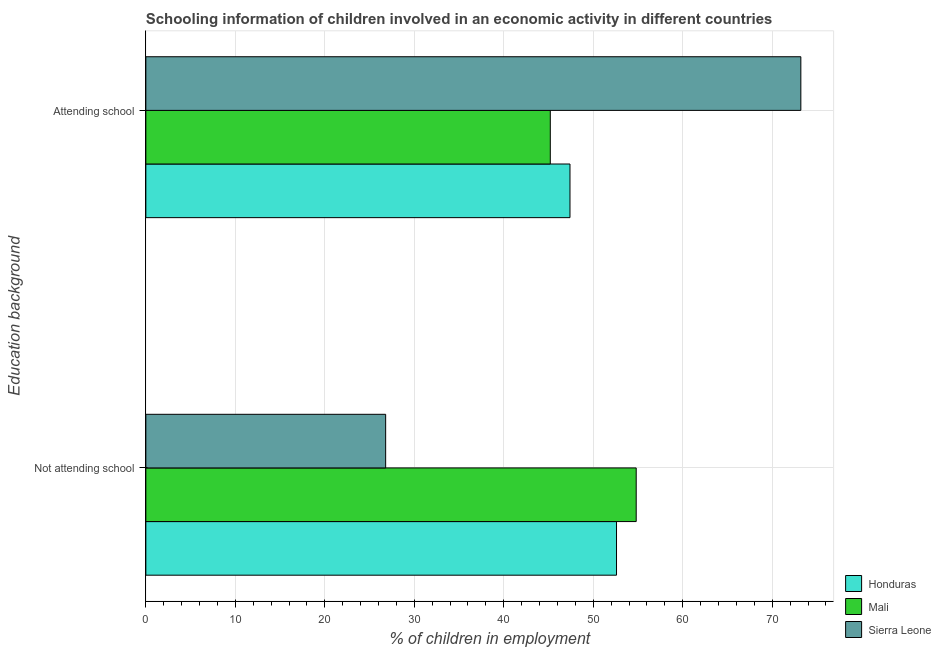How many different coloured bars are there?
Give a very brief answer. 3. Are the number of bars per tick equal to the number of legend labels?
Offer a terse response. Yes. What is the label of the 1st group of bars from the top?
Give a very brief answer. Attending school. What is the percentage of employed children who are attending school in Mali?
Offer a terse response. 45.2. Across all countries, what is the maximum percentage of employed children who are attending school?
Keep it short and to the point. 73.2. Across all countries, what is the minimum percentage of employed children who are not attending school?
Offer a terse response. 26.8. In which country was the percentage of employed children who are attending school maximum?
Offer a very short reply. Sierra Leone. In which country was the percentage of employed children who are not attending school minimum?
Provide a short and direct response. Sierra Leone. What is the total percentage of employed children who are not attending school in the graph?
Offer a terse response. 134.2. What is the difference between the percentage of employed children who are attending school in Sierra Leone and that in Honduras?
Ensure brevity in your answer.  25.8. What is the difference between the percentage of employed children who are not attending school in Mali and the percentage of employed children who are attending school in Honduras?
Keep it short and to the point. 7.4. What is the average percentage of employed children who are not attending school per country?
Ensure brevity in your answer.  44.73. What is the difference between the percentage of employed children who are not attending school and percentage of employed children who are attending school in Honduras?
Give a very brief answer. 5.2. What is the ratio of the percentage of employed children who are not attending school in Honduras to that in Mali?
Give a very brief answer. 0.96. What does the 1st bar from the top in Attending school represents?
Offer a very short reply. Sierra Leone. What does the 2nd bar from the bottom in Not attending school represents?
Offer a terse response. Mali. How many countries are there in the graph?
Keep it short and to the point. 3. What is the difference between two consecutive major ticks on the X-axis?
Your answer should be very brief. 10. Does the graph contain grids?
Provide a short and direct response. Yes. How many legend labels are there?
Offer a very short reply. 3. What is the title of the graph?
Offer a very short reply. Schooling information of children involved in an economic activity in different countries. Does "Mauritania" appear as one of the legend labels in the graph?
Your answer should be compact. No. What is the label or title of the X-axis?
Give a very brief answer. % of children in employment. What is the label or title of the Y-axis?
Offer a very short reply. Education background. What is the % of children in employment of Honduras in Not attending school?
Provide a succinct answer. 52.6. What is the % of children in employment of Mali in Not attending school?
Offer a terse response. 54.8. What is the % of children in employment in Sierra Leone in Not attending school?
Provide a succinct answer. 26.8. What is the % of children in employment in Honduras in Attending school?
Your answer should be very brief. 47.4. What is the % of children in employment of Mali in Attending school?
Offer a very short reply. 45.2. What is the % of children in employment in Sierra Leone in Attending school?
Keep it short and to the point. 73.2. Across all Education background, what is the maximum % of children in employment of Honduras?
Make the answer very short. 52.6. Across all Education background, what is the maximum % of children in employment in Mali?
Provide a short and direct response. 54.8. Across all Education background, what is the maximum % of children in employment in Sierra Leone?
Your answer should be very brief. 73.2. Across all Education background, what is the minimum % of children in employment of Honduras?
Keep it short and to the point. 47.4. Across all Education background, what is the minimum % of children in employment of Mali?
Ensure brevity in your answer.  45.2. Across all Education background, what is the minimum % of children in employment of Sierra Leone?
Provide a succinct answer. 26.8. What is the total % of children in employment of Honduras in the graph?
Offer a terse response. 100. What is the total % of children in employment in Sierra Leone in the graph?
Your answer should be compact. 100. What is the difference between the % of children in employment in Honduras in Not attending school and that in Attending school?
Give a very brief answer. 5.2. What is the difference between the % of children in employment in Mali in Not attending school and that in Attending school?
Offer a terse response. 9.6. What is the difference between the % of children in employment in Sierra Leone in Not attending school and that in Attending school?
Your response must be concise. -46.4. What is the difference between the % of children in employment in Honduras in Not attending school and the % of children in employment in Sierra Leone in Attending school?
Offer a very short reply. -20.6. What is the difference between the % of children in employment in Mali in Not attending school and the % of children in employment in Sierra Leone in Attending school?
Your answer should be very brief. -18.4. What is the average % of children in employment in Mali per Education background?
Ensure brevity in your answer.  50. What is the average % of children in employment of Sierra Leone per Education background?
Make the answer very short. 50. What is the difference between the % of children in employment of Honduras and % of children in employment of Sierra Leone in Not attending school?
Offer a terse response. 25.8. What is the difference between the % of children in employment of Mali and % of children in employment of Sierra Leone in Not attending school?
Keep it short and to the point. 28. What is the difference between the % of children in employment in Honduras and % of children in employment in Mali in Attending school?
Provide a succinct answer. 2.2. What is the difference between the % of children in employment in Honduras and % of children in employment in Sierra Leone in Attending school?
Your answer should be very brief. -25.8. What is the ratio of the % of children in employment in Honduras in Not attending school to that in Attending school?
Keep it short and to the point. 1.11. What is the ratio of the % of children in employment in Mali in Not attending school to that in Attending school?
Provide a succinct answer. 1.21. What is the ratio of the % of children in employment in Sierra Leone in Not attending school to that in Attending school?
Your answer should be very brief. 0.37. What is the difference between the highest and the second highest % of children in employment in Sierra Leone?
Give a very brief answer. 46.4. What is the difference between the highest and the lowest % of children in employment of Sierra Leone?
Give a very brief answer. 46.4. 